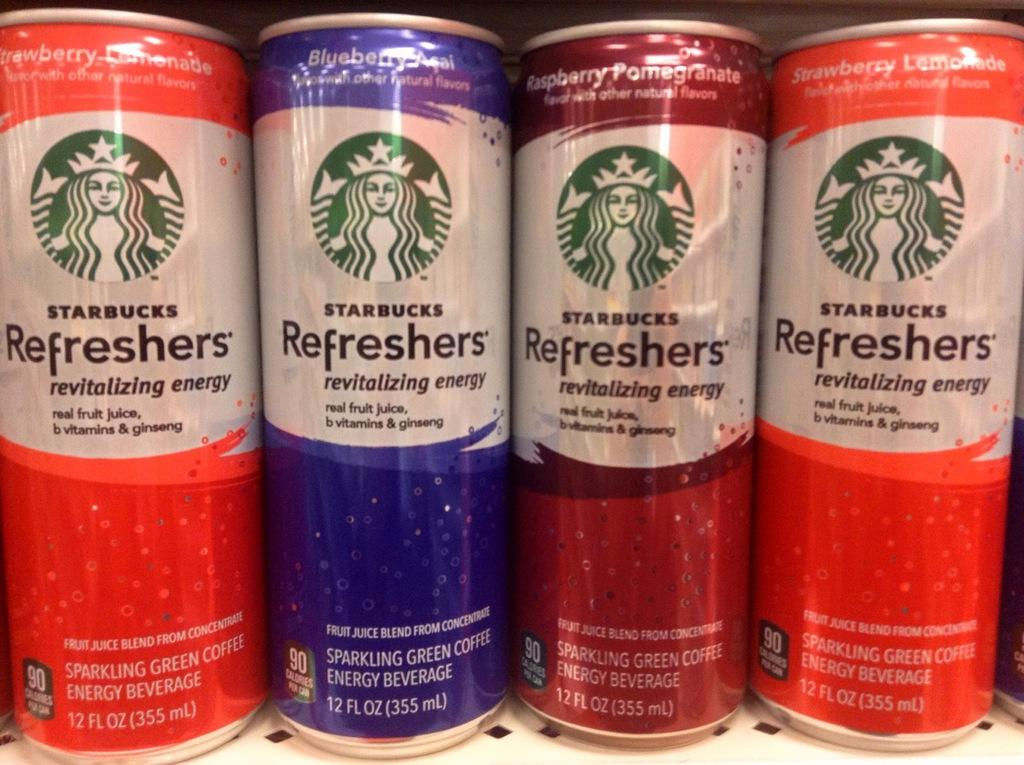<image>
Create a compact narrative representing the image presented. Four cans of Starbucks Refreshers are lined up on a shelf. 